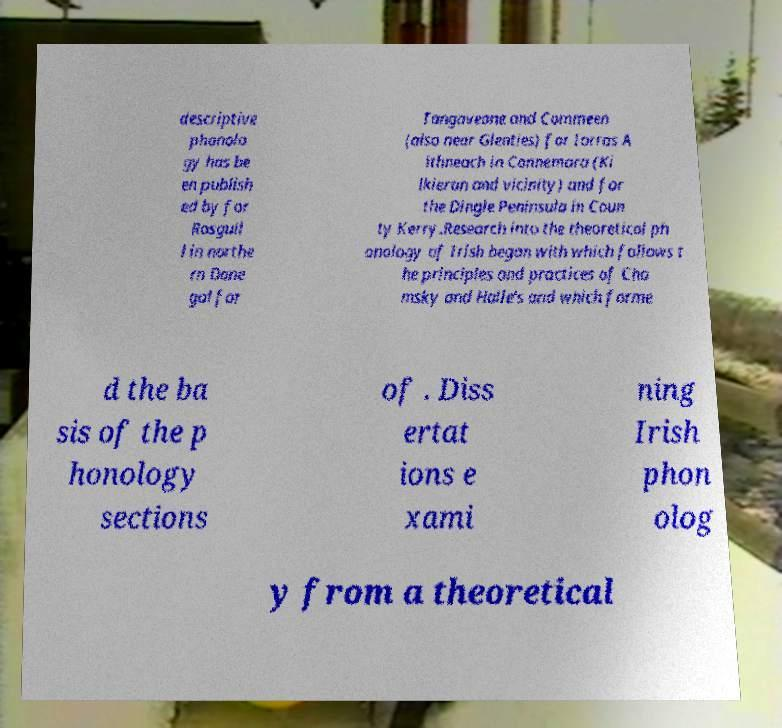Please read and relay the text visible in this image. What does it say? descriptive phonolo gy has be en publish ed by for Rosguil l in northe rn Done gal for Tangaveane and Commeen (also near Glenties) for Iorras A ithneach in Connemara (Ki lkieran and vicinity) and for the Dingle Peninsula in Coun ty Kerry.Research into the theoretical ph onology of Irish began with which follows t he principles and practices of Cho msky and Halle's and which forme d the ba sis of the p honology sections of . Diss ertat ions e xami ning Irish phon olog y from a theoretical 